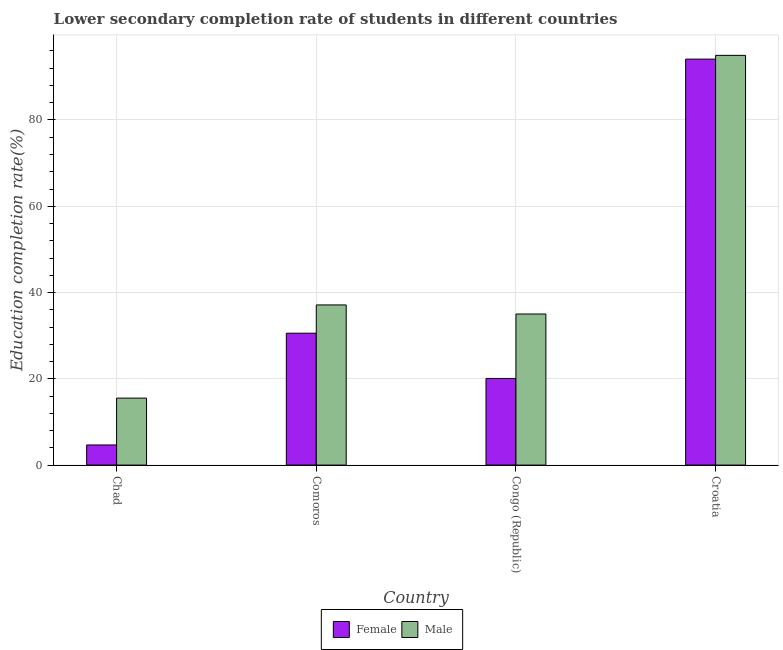How many different coloured bars are there?
Offer a very short reply. 2. How many bars are there on the 3rd tick from the right?
Provide a short and direct response. 2. What is the label of the 4th group of bars from the left?
Offer a very short reply. Croatia. In how many cases, is the number of bars for a given country not equal to the number of legend labels?
Keep it short and to the point. 0. What is the education completion rate of male students in Croatia?
Offer a terse response. 94.98. Across all countries, what is the maximum education completion rate of female students?
Your answer should be compact. 94.11. Across all countries, what is the minimum education completion rate of female students?
Your answer should be compact. 4.66. In which country was the education completion rate of female students maximum?
Provide a short and direct response. Croatia. In which country was the education completion rate of female students minimum?
Provide a succinct answer. Chad. What is the total education completion rate of female students in the graph?
Offer a very short reply. 149.43. What is the difference between the education completion rate of male students in Congo (Republic) and that in Croatia?
Offer a very short reply. -59.96. What is the difference between the education completion rate of female students in Congo (Republic) and the education completion rate of male students in Chad?
Ensure brevity in your answer.  4.56. What is the average education completion rate of male students per country?
Provide a short and direct response. 45.66. What is the difference between the education completion rate of female students and education completion rate of male students in Comoros?
Give a very brief answer. -6.55. In how many countries, is the education completion rate of male students greater than 84 %?
Offer a very short reply. 1. What is the ratio of the education completion rate of male students in Congo (Republic) to that in Croatia?
Your response must be concise. 0.37. Is the education completion rate of male students in Chad less than that in Comoros?
Your answer should be compact. Yes. Is the difference between the education completion rate of female students in Congo (Republic) and Croatia greater than the difference between the education completion rate of male students in Congo (Republic) and Croatia?
Offer a very short reply. No. What is the difference between the highest and the second highest education completion rate of female students?
Offer a terse response. 63.54. What is the difference between the highest and the lowest education completion rate of male students?
Provide a short and direct response. 79.46. Is the sum of the education completion rate of male students in Comoros and Croatia greater than the maximum education completion rate of female students across all countries?
Provide a short and direct response. Yes. What does the 2nd bar from the right in Comoros represents?
Give a very brief answer. Female. Are all the bars in the graph horizontal?
Provide a short and direct response. No. How many countries are there in the graph?
Offer a very short reply. 4. Does the graph contain grids?
Give a very brief answer. Yes. Where does the legend appear in the graph?
Ensure brevity in your answer.  Bottom center. How many legend labels are there?
Offer a very short reply. 2. What is the title of the graph?
Make the answer very short. Lower secondary completion rate of students in different countries. What is the label or title of the Y-axis?
Provide a succinct answer. Education completion rate(%). What is the Education completion rate(%) of Female in Chad?
Your answer should be very brief. 4.66. What is the Education completion rate(%) in Male in Chad?
Make the answer very short. 15.52. What is the Education completion rate(%) in Female in Comoros?
Your response must be concise. 30.57. What is the Education completion rate(%) in Male in Comoros?
Your answer should be compact. 37.13. What is the Education completion rate(%) in Female in Congo (Republic)?
Keep it short and to the point. 20.08. What is the Education completion rate(%) of Male in Congo (Republic)?
Keep it short and to the point. 35.02. What is the Education completion rate(%) of Female in Croatia?
Offer a very short reply. 94.11. What is the Education completion rate(%) in Male in Croatia?
Offer a terse response. 94.98. Across all countries, what is the maximum Education completion rate(%) of Female?
Make the answer very short. 94.11. Across all countries, what is the maximum Education completion rate(%) in Male?
Your response must be concise. 94.98. Across all countries, what is the minimum Education completion rate(%) of Female?
Offer a terse response. 4.66. Across all countries, what is the minimum Education completion rate(%) in Male?
Ensure brevity in your answer.  15.52. What is the total Education completion rate(%) in Female in the graph?
Offer a very short reply. 149.43. What is the total Education completion rate(%) in Male in the graph?
Provide a succinct answer. 182.65. What is the difference between the Education completion rate(%) in Female in Chad and that in Comoros?
Your response must be concise. -25.91. What is the difference between the Education completion rate(%) in Male in Chad and that in Comoros?
Provide a succinct answer. -21.61. What is the difference between the Education completion rate(%) in Female in Chad and that in Congo (Republic)?
Offer a very short reply. -15.42. What is the difference between the Education completion rate(%) of Male in Chad and that in Congo (Republic)?
Make the answer very short. -19.5. What is the difference between the Education completion rate(%) in Female in Chad and that in Croatia?
Offer a terse response. -89.45. What is the difference between the Education completion rate(%) in Male in Chad and that in Croatia?
Make the answer very short. -79.46. What is the difference between the Education completion rate(%) of Female in Comoros and that in Congo (Republic)?
Ensure brevity in your answer.  10.49. What is the difference between the Education completion rate(%) of Male in Comoros and that in Congo (Republic)?
Provide a short and direct response. 2.11. What is the difference between the Education completion rate(%) in Female in Comoros and that in Croatia?
Give a very brief answer. -63.54. What is the difference between the Education completion rate(%) in Male in Comoros and that in Croatia?
Your answer should be compact. -57.86. What is the difference between the Education completion rate(%) in Female in Congo (Republic) and that in Croatia?
Offer a terse response. -74.03. What is the difference between the Education completion rate(%) of Male in Congo (Republic) and that in Croatia?
Keep it short and to the point. -59.96. What is the difference between the Education completion rate(%) of Female in Chad and the Education completion rate(%) of Male in Comoros?
Your response must be concise. -32.47. What is the difference between the Education completion rate(%) in Female in Chad and the Education completion rate(%) in Male in Congo (Republic)?
Give a very brief answer. -30.36. What is the difference between the Education completion rate(%) in Female in Chad and the Education completion rate(%) in Male in Croatia?
Provide a succinct answer. -90.32. What is the difference between the Education completion rate(%) in Female in Comoros and the Education completion rate(%) in Male in Congo (Republic)?
Your answer should be compact. -4.45. What is the difference between the Education completion rate(%) of Female in Comoros and the Education completion rate(%) of Male in Croatia?
Your answer should be very brief. -64.41. What is the difference between the Education completion rate(%) in Female in Congo (Republic) and the Education completion rate(%) in Male in Croatia?
Make the answer very short. -74.9. What is the average Education completion rate(%) in Female per country?
Make the answer very short. 37.36. What is the average Education completion rate(%) of Male per country?
Give a very brief answer. 45.66. What is the difference between the Education completion rate(%) in Female and Education completion rate(%) in Male in Chad?
Your response must be concise. -10.86. What is the difference between the Education completion rate(%) in Female and Education completion rate(%) in Male in Comoros?
Give a very brief answer. -6.55. What is the difference between the Education completion rate(%) of Female and Education completion rate(%) of Male in Congo (Republic)?
Your answer should be compact. -14.94. What is the difference between the Education completion rate(%) in Female and Education completion rate(%) in Male in Croatia?
Make the answer very short. -0.87. What is the ratio of the Education completion rate(%) of Female in Chad to that in Comoros?
Provide a short and direct response. 0.15. What is the ratio of the Education completion rate(%) in Male in Chad to that in Comoros?
Your answer should be compact. 0.42. What is the ratio of the Education completion rate(%) in Female in Chad to that in Congo (Republic)?
Offer a terse response. 0.23. What is the ratio of the Education completion rate(%) in Male in Chad to that in Congo (Republic)?
Offer a very short reply. 0.44. What is the ratio of the Education completion rate(%) in Female in Chad to that in Croatia?
Offer a very short reply. 0.05. What is the ratio of the Education completion rate(%) of Male in Chad to that in Croatia?
Give a very brief answer. 0.16. What is the ratio of the Education completion rate(%) in Female in Comoros to that in Congo (Republic)?
Offer a terse response. 1.52. What is the ratio of the Education completion rate(%) of Male in Comoros to that in Congo (Republic)?
Ensure brevity in your answer.  1.06. What is the ratio of the Education completion rate(%) of Female in Comoros to that in Croatia?
Provide a short and direct response. 0.32. What is the ratio of the Education completion rate(%) of Male in Comoros to that in Croatia?
Your answer should be very brief. 0.39. What is the ratio of the Education completion rate(%) of Female in Congo (Republic) to that in Croatia?
Ensure brevity in your answer.  0.21. What is the ratio of the Education completion rate(%) in Male in Congo (Republic) to that in Croatia?
Make the answer very short. 0.37. What is the difference between the highest and the second highest Education completion rate(%) of Female?
Your response must be concise. 63.54. What is the difference between the highest and the second highest Education completion rate(%) in Male?
Provide a succinct answer. 57.86. What is the difference between the highest and the lowest Education completion rate(%) of Female?
Your answer should be compact. 89.45. What is the difference between the highest and the lowest Education completion rate(%) in Male?
Keep it short and to the point. 79.46. 